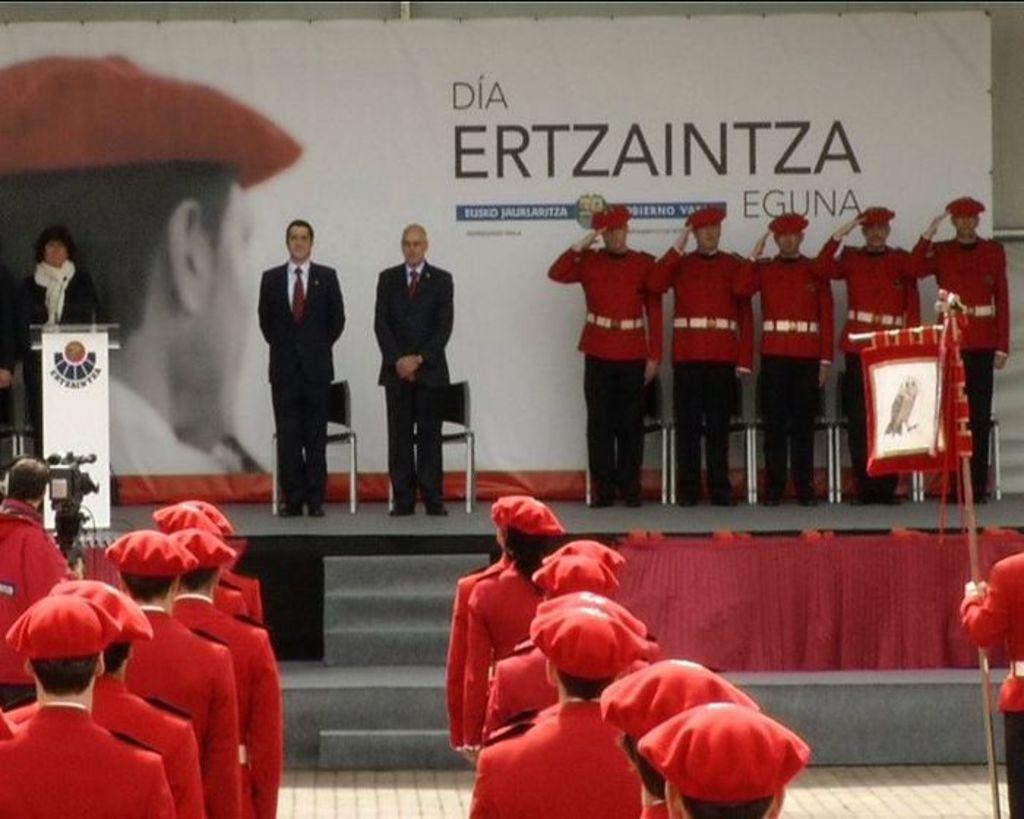Please provide a concise description of this image. In this picture I can see few people standing and I can see a podium and few chairs on the dais and I can see few people wore caps on their heads and a man holding a flag and I can see an advertisement board with some text in the back. 